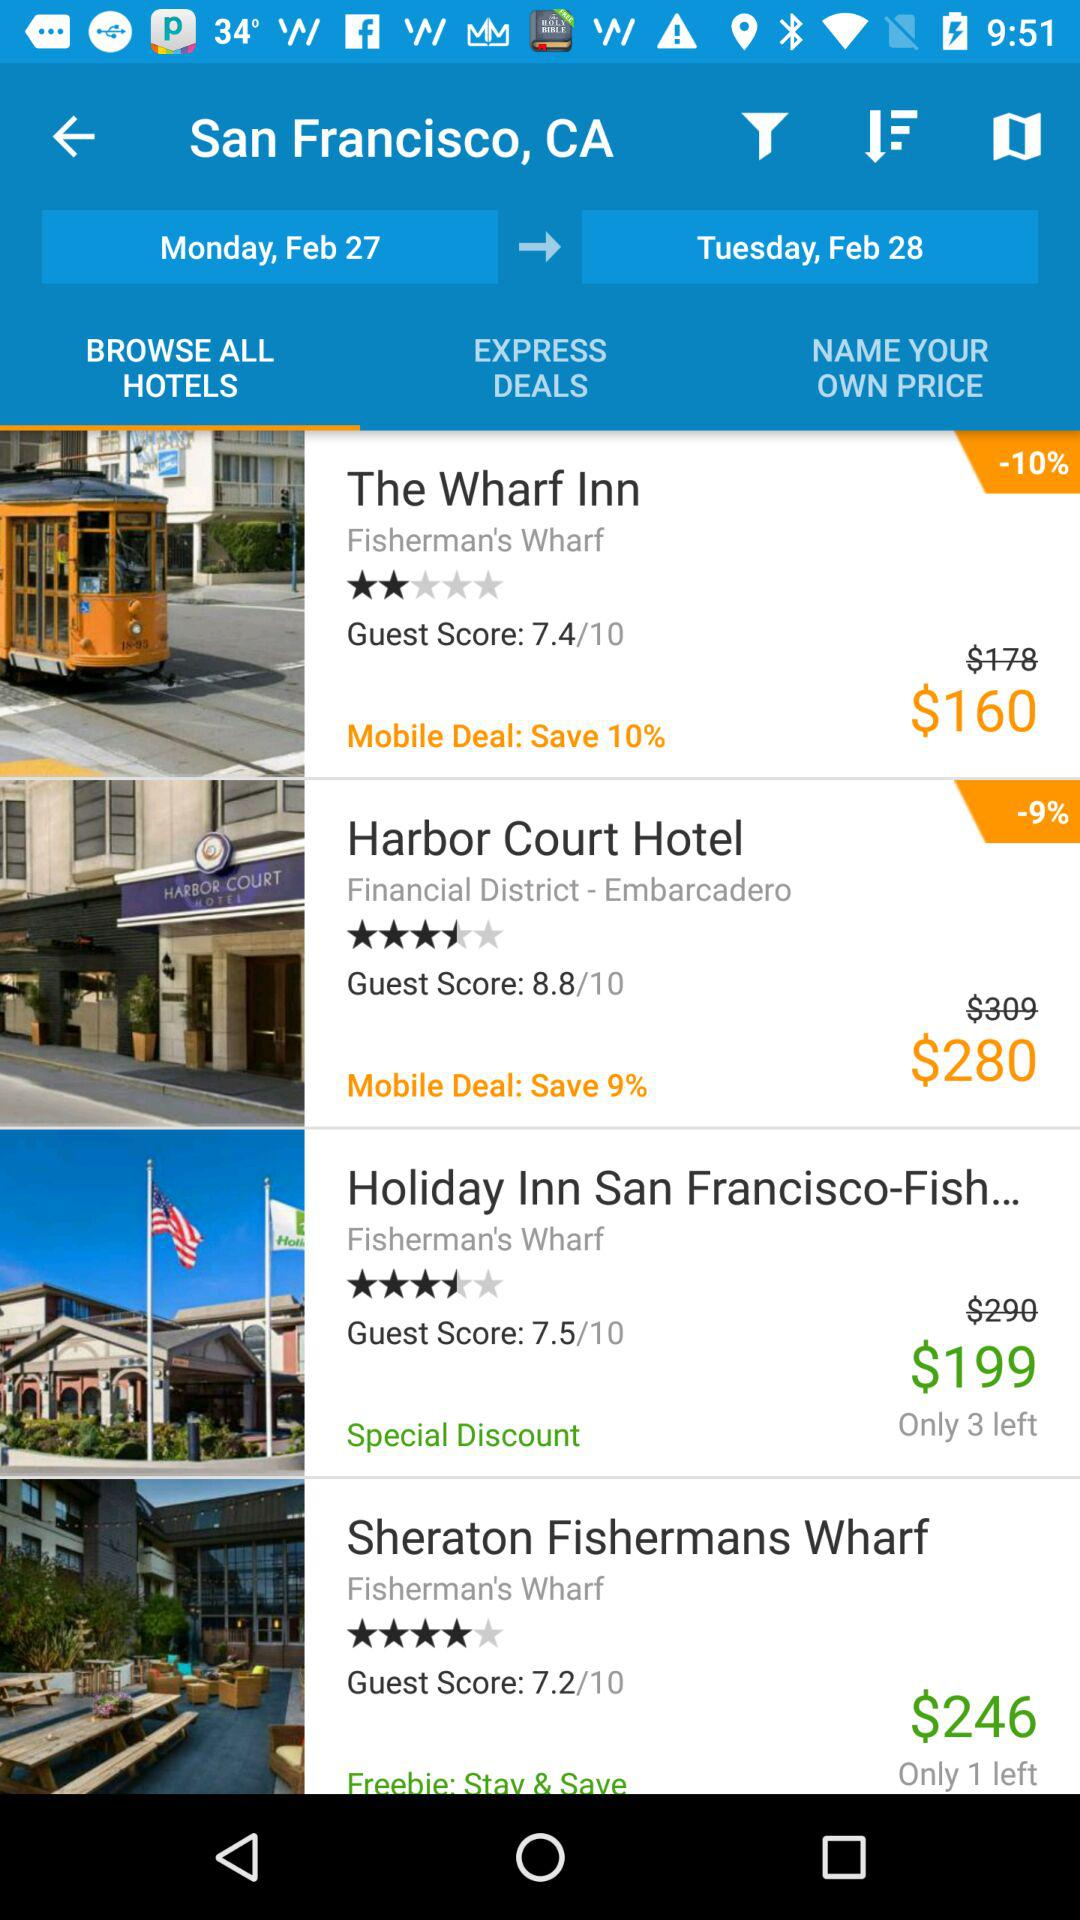Which hotel has the highest guest rating?
Answer the question using a single word or phrase. Harbor Court Hotel 